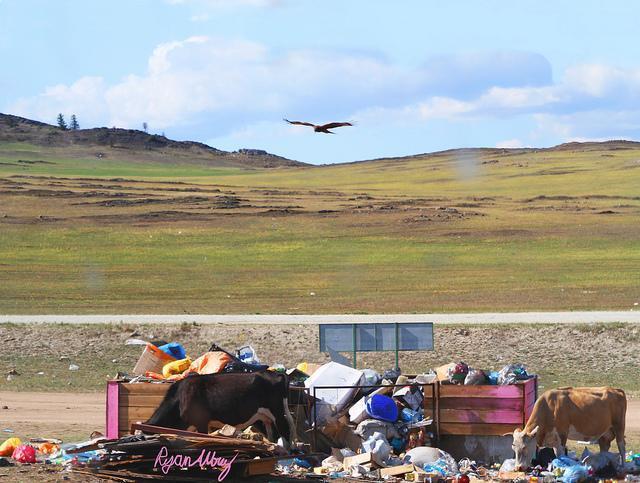How many cows are in the picture?
Give a very brief answer. 2. 